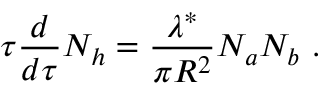<formula> <loc_0><loc_0><loc_500><loc_500>\tau { \frac { d } { d \tau } } N _ { h } = { \frac { \lambda ^ { * } } { \pi R ^ { 2 } } } N _ { a } N _ { b } \ .</formula> 